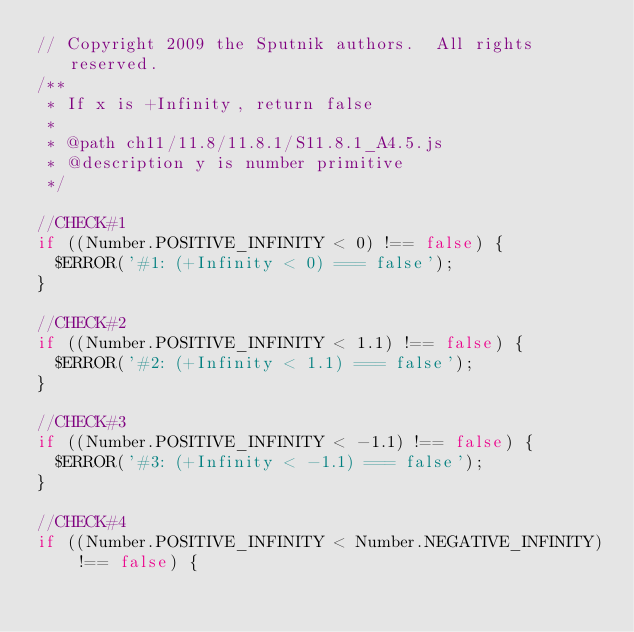<code> <loc_0><loc_0><loc_500><loc_500><_JavaScript_>// Copyright 2009 the Sputnik authors.  All rights reserved.
/**
 * If x is +Infinity, return false
 *
 * @path ch11/11.8/11.8.1/S11.8.1_A4.5.js
 * @description y is number primitive
 */

//CHECK#1
if ((Number.POSITIVE_INFINITY < 0) !== false) {
  $ERROR('#1: (+Infinity < 0) === false');
}

//CHECK#2
if ((Number.POSITIVE_INFINITY < 1.1) !== false) {
  $ERROR('#2: (+Infinity < 1.1) === false');
}

//CHECK#3
if ((Number.POSITIVE_INFINITY < -1.1) !== false) {
  $ERROR('#3: (+Infinity < -1.1) === false');
}

//CHECK#4
if ((Number.POSITIVE_INFINITY < Number.NEGATIVE_INFINITY) !== false) {</code> 